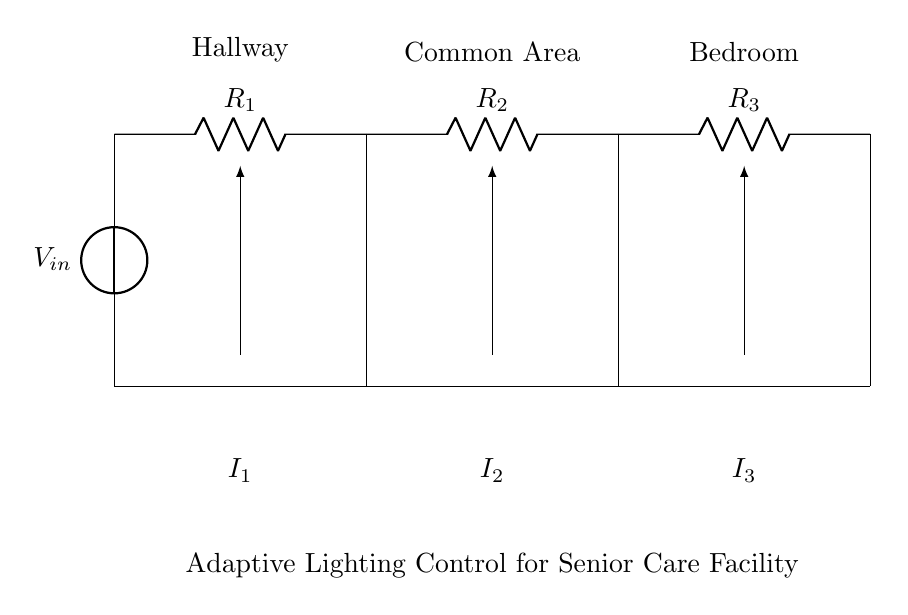What is the total number of resistors in the circuit? There are three resistors connected in a series configuration, labeled as R1, R2, and R3.
Answer: 3 What area does the first LED light up? The first LED is connected to the current path labeled for the Hallway, indicating that it lights up that area.
Answer: Hallway What is the role of the voltage source in this circuit? The voltage source provides the electrical energy necessary to drive the currents through the resistors and LEDs, thus enabling their operation.
Answer: Power supply How does current get divided in this circuit? The current from the voltage source splits among the resistors R1, R2, and R3 based on their resistances according to the current divider rule, affecting the brightness of respective LEDs.
Answer: Current division Which area has a direct path to the most resistance? The area with R3 has a direct path to the most resistance since it is at the end of the series of resistors, meaning R3 will limit current more than R1 or R2.
Answer: Bedroom What happens to current if R2 is removed? If R2 is removed, the total resistance decreases, leading to an increase in total current from the voltage source, thereby affecting the current distribution to R1 and R3.
Answer: Increases current 